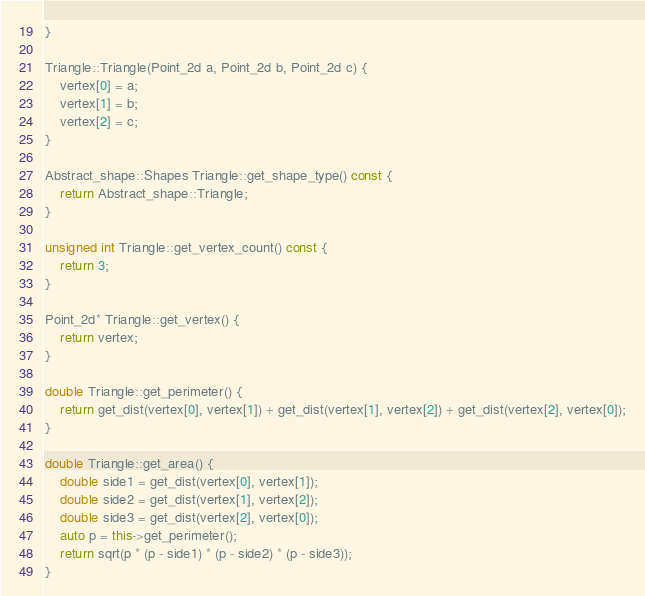Convert code to text. <code><loc_0><loc_0><loc_500><loc_500><_C++_>}

Triangle::Triangle(Point_2d a, Point_2d b, Point_2d c) {
    vertex[0] = a;
    vertex[1] = b;
    vertex[2] = c;
}

Abstract_shape::Shapes Triangle::get_shape_type() const {
    return Abstract_shape::Triangle;
}

unsigned int Triangle::get_vertex_count() const {
    return 3;
}

Point_2d* Triangle::get_vertex() {
    return vertex;
}

double Triangle::get_perimeter() {
    return get_dist(vertex[0], vertex[1]) + get_dist(vertex[1], vertex[2]) + get_dist(vertex[2], vertex[0]);
}

double Triangle::get_area() {
    double side1 = get_dist(vertex[0], vertex[1]);
    double side2 = get_dist(vertex[1], vertex[2]);
    double side3 = get_dist(vertex[2], vertex[0]);
    auto p = this->get_perimeter();
    return sqrt(p * (p - side1) * (p - side2) * (p - side3));
}
</code> 